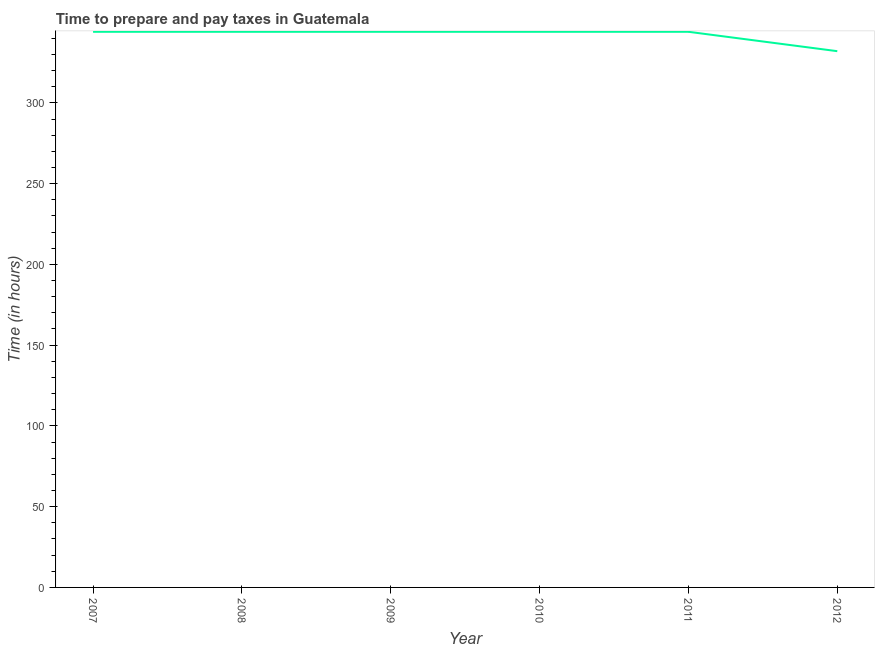What is the time to prepare and pay taxes in 2008?
Your answer should be very brief. 344. Across all years, what is the maximum time to prepare and pay taxes?
Your answer should be compact. 344. Across all years, what is the minimum time to prepare and pay taxes?
Offer a terse response. 332. In which year was the time to prepare and pay taxes minimum?
Keep it short and to the point. 2012. What is the sum of the time to prepare and pay taxes?
Offer a terse response. 2052. What is the average time to prepare and pay taxes per year?
Give a very brief answer. 342. What is the median time to prepare and pay taxes?
Provide a short and direct response. 344. What is the ratio of the time to prepare and pay taxes in 2008 to that in 2012?
Your answer should be very brief. 1.04. Is the time to prepare and pay taxes in 2007 less than that in 2010?
Your answer should be very brief. No. Is the sum of the time to prepare and pay taxes in 2007 and 2009 greater than the maximum time to prepare and pay taxes across all years?
Give a very brief answer. Yes. What is the difference between the highest and the lowest time to prepare and pay taxes?
Provide a short and direct response. 12. In how many years, is the time to prepare and pay taxes greater than the average time to prepare and pay taxes taken over all years?
Offer a very short reply. 5. How many lines are there?
Offer a very short reply. 1. How many years are there in the graph?
Make the answer very short. 6. What is the difference between two consecutive major ticks on the Y-axis?
Keep it short and to the point. 50. Does the graph contain any zero values?
Keep it short and to the point. No. Does the graph contain grids?
Ensure brevity in your answer.  No. What is the title of the graph?
Your answer should be compact. Time to prepare and pay taxes in Guatemala. What is the label or title of the Y-axis?
Ensure brevity in your answer.  Time (in hours). What is the Time (in hours) in 2007?
Offer a very short reply. 344. What is the Time (in hours) of 2008?
Provide a succinct answer. 344. What is the Time (in hours) of 2009?
Provide a succinct answer. 344. What is the Time (in hours) in 2010?
Ensure brevity in your answer.  344. What is the Time (in hours) of 2011?
Ensure brevity in your answer.  344. What is the Time (in hours) of 2012?
Keep it short and to the point. 332. What is the difference between the Time (in hours) in 2007 and 2008?
Ensure brevity in your answer.  0. What is the difference between the Time (in hours) in 2008 and 2010?
Provide a succinct answer. 0. What is the difference between the Time (in hours) in 2009 and 2011?
Make the answer very short. 0. What is the difference between the Time (in hours) in 2010 and 2012?
Your answer should be compact. 12. What is the ratio of the Time (in hours) in 2007 to that in 2008?
Give a very brief answer. 1. What is the ratio of the Time (in hours) in 2007 to that in 2010?
Your answer should be compact. 1. What is the ratio of the Time (in hours) in 2007 to that in 2011?
Provide a succinct answer. 1. What is the ratio of the Time (in hours) in 2007 to that in 2012?
Ensure brevity in your answer.  1.04. What is the ratio of the Time (in hours) in 2008 to that in 2010?
Make the answer very short. 1. What is the ratio of the Time (in hours) in 2008 to that in 2012?
Your answer should be compact. 1.04. What is the ratio of the Time (in hours) in 2009 to that in 2011?
Your response must be concise. 1. What is the ratio of the Time (in hours) in 2009 to that in 2012?
Offer a very short reply. 1.04. What is the ratio of the Time (in hours) in 2010 to that in 2011?
Offer a terse response. 1. What is the ratio of the Time (in hours) in 2010 to that in 2012?
Ensure brevity in your answer.  1.04. What is the ratio of the Time (in hours) in 2011 to that in 2012?
Offer a terse response. 1.04. 